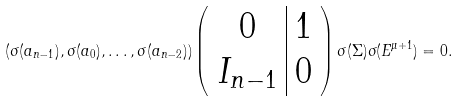Convert formula to latex. <formula><loc_0><loc_0><loc_500><loc_500>( \sigma ( a _ { n - 1 } ) , \sigma ( a _ { 0 } ) , \dots , \sigma ( a _ { n - 2 } ) ) \left ( \begin{array} { c | c } 0 & 1 \\ I _ { n - 1 } & 0 \end{array} \right ) \sigma ( \Sigma ) \sigma ( E ^ { \mu + 1 } ) = 0 .</formula> 